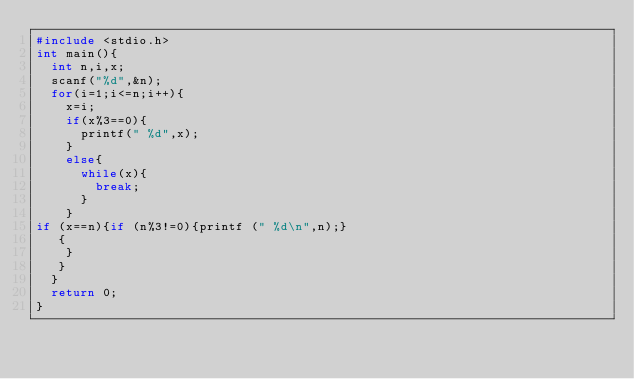Convert code to text. <code><loc_0><loc_0><loc_500><loc_500><_C_>#include <stdio.h>
int main(){
  int n,i,x;
  scanf("%d",&n);
  for(i=1;i<=n;i++){
    x=i;
    if(x%3==0){
      printf(" %d",x);
    }
    else{
      while(x){
        break;
      }
    }
if (x==n){if (n%3!=0){printf (" %d\n",n);}
   {
    }
   }
  }
  return 0;
}
</code> 